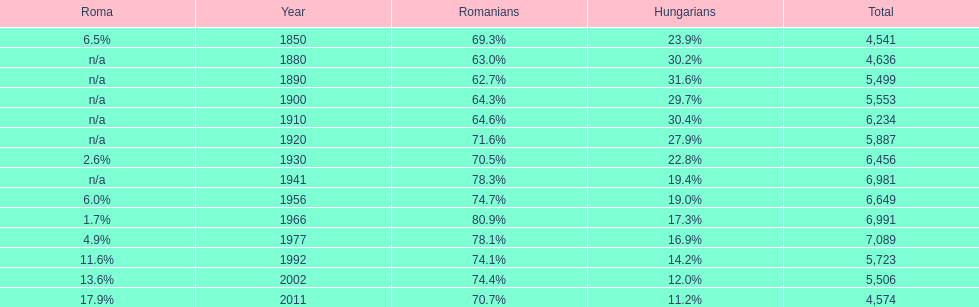What year had the highest total number? 1977. 